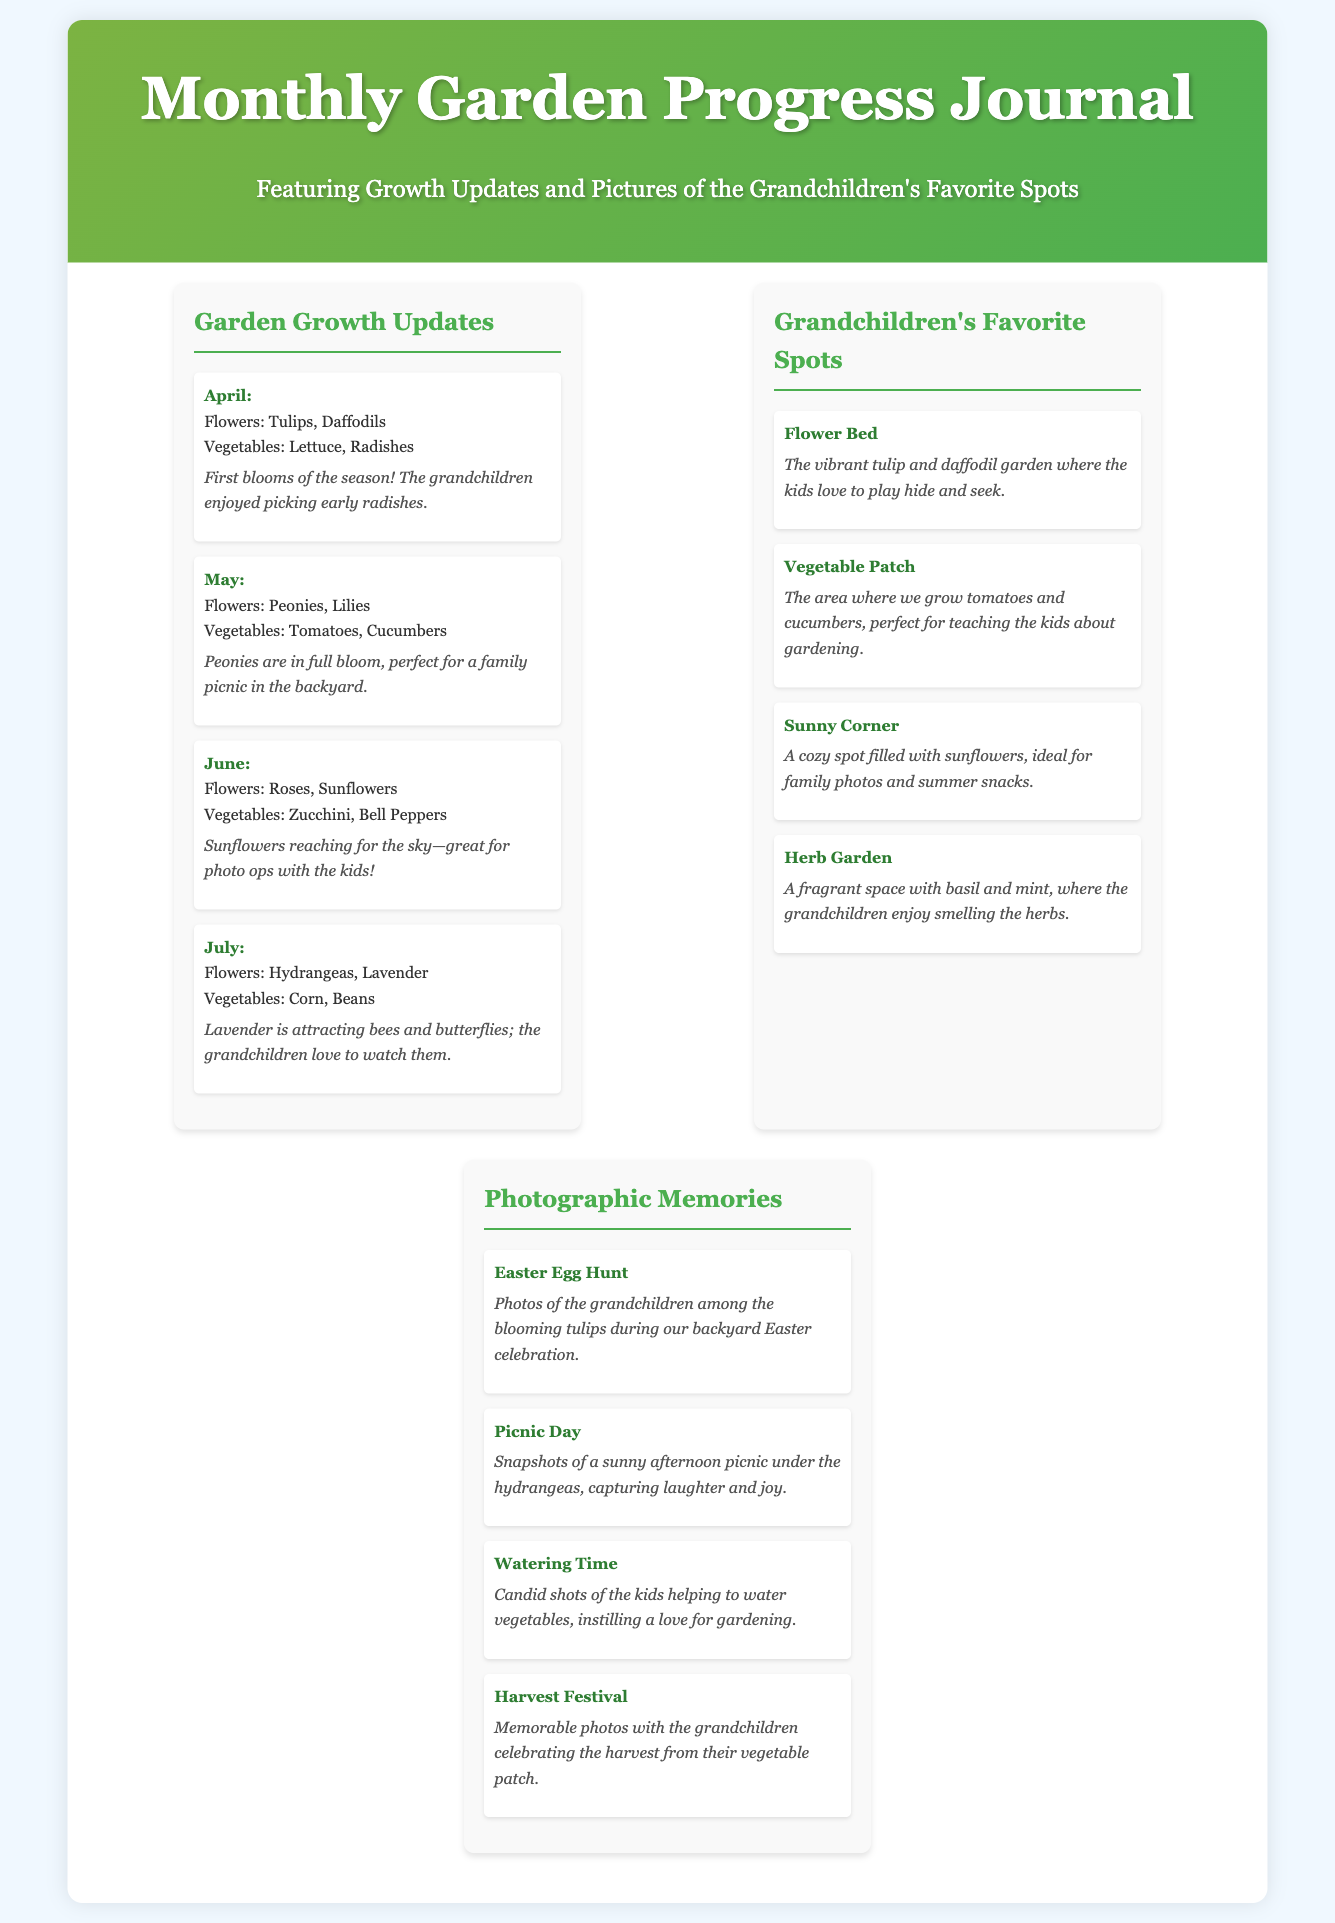What month features sunflowers? The document lists sunflowers as growing in June.
Answer: June What is grown in the vegetable patch? The description mentions tomatoes and cucumbers are grown in the vegetable patch.
Answer: Tomatoes and cucumbers Which event features kids among tulips? The event where the grandchildren are among the blooming tulips is the Easter Egg Hunt.
Answer: Easter Egg Hunt How many months of garden updates are provided? The document provides updates for four months: April, May, June, and July.
Answer: Four What flowers bloom in May? The flowers listed for May are peonies and lilies.
Answer: Peonies, Lilies What is the description for the sunny corner? The sunny corner is described as ideal for family photos and summer snacks.
Answer: Ideal for family photos and summer snacks Which month is associated with lavender? The month when lavender blooms and attracts bees is July.
Answer: July Which event captures laughter and joy under hydrangeas? The event that captures laughter and joy is the Picnic Day.
Answer: Picnic Day 